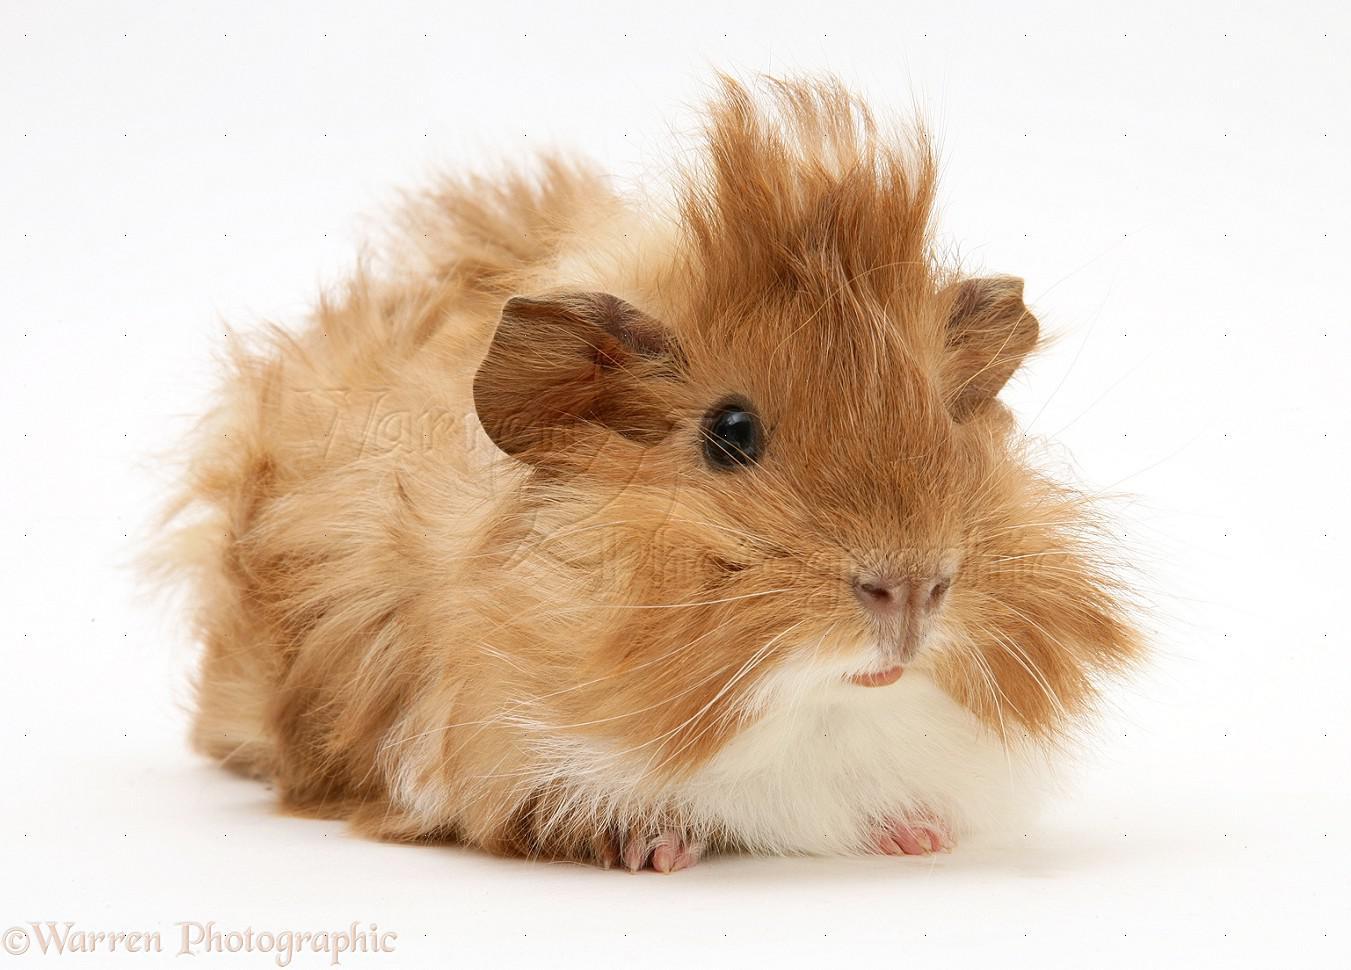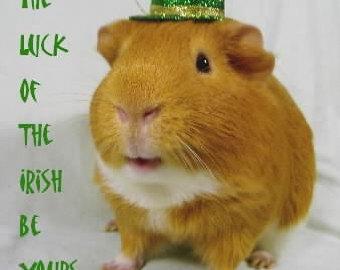The first image is the image on the left, the second image is the image on the right. For the images shown, is this caption "There are two different guinea pigs featured here." true? Answer yes or no. Yes. 